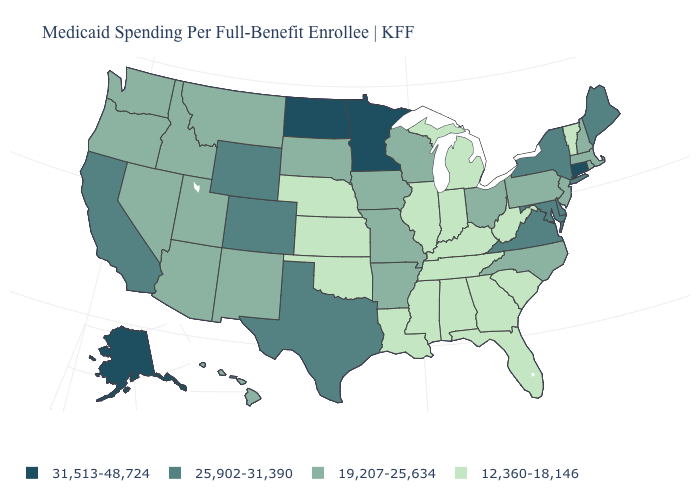Name the states that have a value in the range 12,360-18,146?
Keep it brief. Alabama, Florida, Georgia, Illinois, Indiana, Kansas, Kentucky, Louisiana, Michigan, Mississippi, Nebraska, Oklahoma, South Carolina, Tennessee, Vermont, West Virginia. Is the legend a continuous bar?
Be succinct. No. Name the states that have a value in the range 25,902-31,390?
Answer briefly. California, Colorado, Delaware, Maine, Maryland, New York, Texas, Virginia, Wyoming. Which states have the lowest value in the MidWest?
Write a very short answer. Illinois, Indiana, Kansas, Michigan, Nebraska. How many symbols are there in the legend?
Concise answer only. 4. What is the highest value in states that border Rhode Island?
Concise answer only. 31,513-48,724. Does the map have missing data?
Keep it brief. No. What is the highest value in the South ?
Be succinct. 25,902-31,390. What is the value of Connecticut?
Write a very short answer. 31,513-48,724. Which states have the lowest value in the USA?
Quick response, please. Alabama, Florida, Georgia, Illinois, Indiana, Kansas, Kentucky, Louisiana, Michigan, Mississippi, Nebraska, Oklahoma, South Carolina, Tennessee, Vermont, West Virginia. What is the highest value in the USA?
Concise answer only. 31,513-48,724. What is the highest value in states that border Mississippi?
Quick response, please. 19,207-25,634. How many symbols are there in the legend?
Write a very short answer. 4. Does Virginia have the lowest value in the USA?
Give a very brief answer. No. Does the map have missing data?
Give a very brief answer. No. 